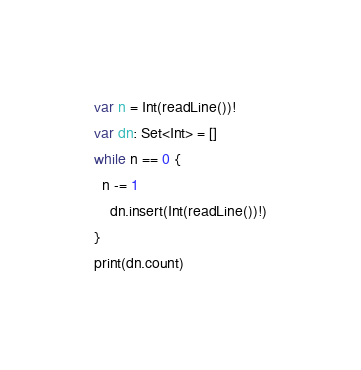<code> <loc_0><loc_0><loc_500><loc_500><_Swift_>var n = Int(readLine())!
var dn: Set<Int> = []
while n == 0 {
  n -= 1
    dn.insert(Int(readLine())!)
}
print(dn.count)</code> 